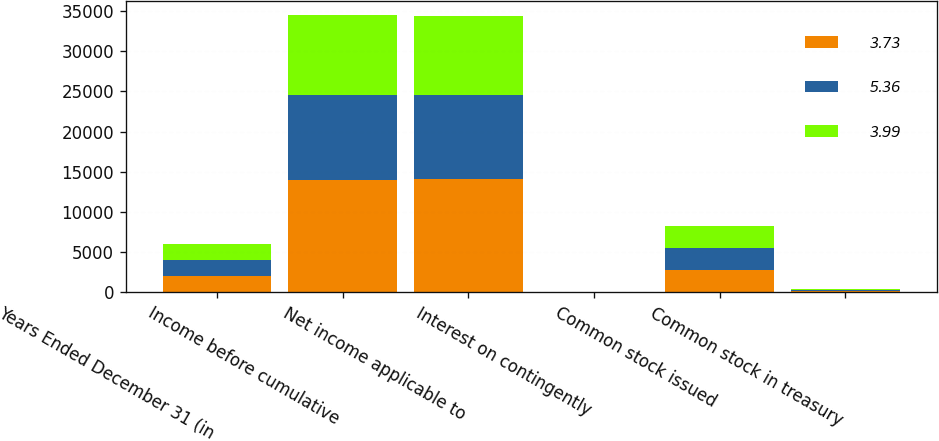Convert chart to OTSL. <chart><loc_0><loc_0><loc_500><loc_500><stacked_bar_chart><ecel><fcel>Years Ended December 31 (in<fcel>Income before cumulative<fcel>Net income applicable to<fcel>Interest on contingently<fcel>Common stock issued<fcel>Common stock in treasury<nl><fcel>3.73<fcel>2006<fcel>14024<fcel>14058<fcel>10<fcel>2751<fcel>153<nl><fcel>5.36<fcel>2005<fcel>10488<fcel>10488<fcel>11<fcel>2751<fcel>155<nl><fcel>3.99<fcel>2004<fcel>9994<fcel>9850<fcel>11<fcel>2751<fcel>146<nl></chart> 